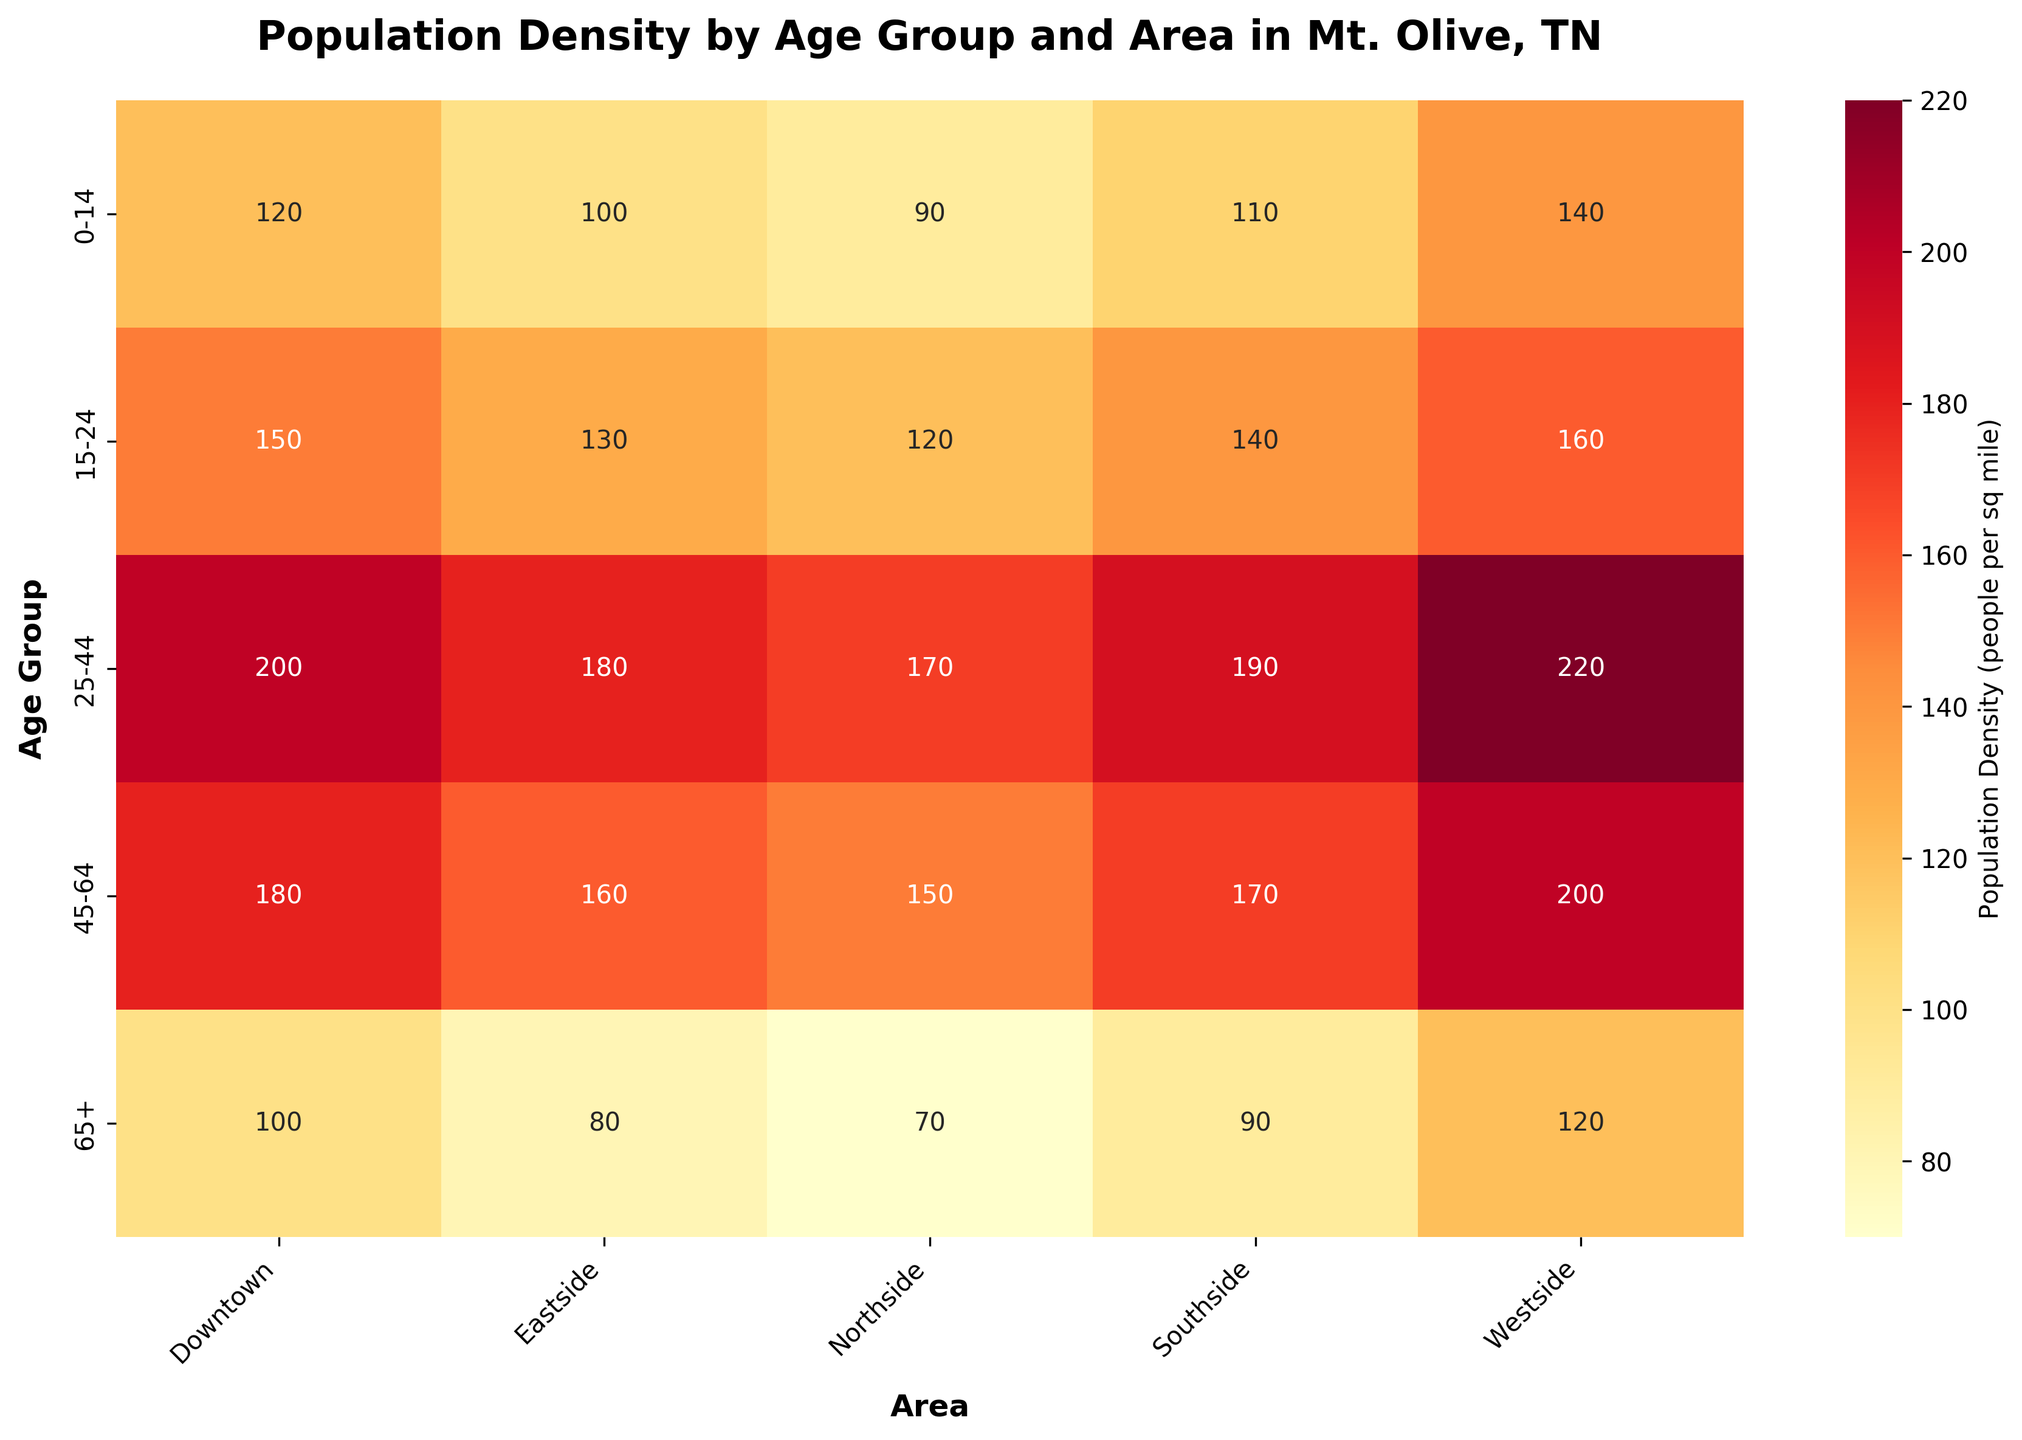How many age groups are represented in the heatmap? The heatmap shows five different age groups vertically along the y-axis. These age groups are 0-14, 15-24, 25-44, 45-64, and 65+.
Answer: 5 What's the total population density for the 'Downtown' area across all age groups? To find the total population density for the 'Downtown' area, sum the values for each age group: 120 (0-14) + 150 (15-24) + 200 (25-44) + 180 (45-64) + 100 (65+). The total is 750.
Answer: 750 Which age group has the highest population density in the 'Westside' area? By looking at the 'Westside' column, you can see that the values for each age group are 140 (0-14), 160 (15-24), 220 (25-44), 200 (45-64), and 120 (65+). The highest density is 220 for the age group 25-44.
Answer: 25-44 How does the population density for the age group 65+ in 'Eastside' compare to 'Southside'? The population density for the age group 65+ in the 'Eastside' is 80 and in the 'Southside' is 90. Comparing these, the 'Southside' has a higher population density.
Answer: Southside has a higher population density What is the average population density for the age group 15-24 across all areas? Calculate the average by summing the densities for the age group 15-24 across all areas and then dividing by the number of areas: (150+130+160+120+140) / 5 = 700 / 5 = 140.
Answer: 140 Which area has the lowest population density for the age group 45-64? By examining the values for the age group 45-64 across all areas: Downtown (180), Eastside (160), Westside (200), Northside (150), Southside (170), the lowest density is in 'Northside' with 150.
Answer: Northside In which area is the population density for the 25-44 age group higher than both the 15-24 and 45-64 age groups? Look at each area where the 25-44 density is higher than both 15-24 and 45-64: 
- Downtown: 200 (25-44) > 150 (15-24) & 200 > 180 (45-64) ✅
- Eastside: 180 (25-44) > 130 (15-24) & 180 > 160 (45-64) ✅
- Westside: 220 (25-44) > 160 (15-24) & 220 > 200 (45-64) ✅
- Northside: 170 (25-44) > 120 (15-24) & 170 > 150 (45-64) ✅
- Southside: 190 (25-44) > 140 (15-24) & 190 > 170 (45-64) ✅
All areas have higher population density in the 25-44 age group compared to both 15-24 and 45-64 age groups.
Answer: All areas Which combination of age group and area has the lowest population density? By scanning the heatmap, the lowest population density value is 70, which corresponds to the 65+ age group in the 'Northside' area.
Answer: 65+ in Northside Is the population density for the 25-44 age group in 'Southside' greater than the population densities for the 0-14 and 65+ age groups in 'Downtown'? Compare the values: 
- 25-44 in 'Southside': 190 
- 0-14 in 'Downtown': 120 
- 65+ in 'Downtown': 100
190 (Southside 25-44) > 120 (Downtown 0-14) & 190 > 100 (Downtown 65+). So, it is greater.
Answer: Yes Considering all areas, which age group shows the highest variation in population density? To determine this, observe the ranges (difference between highest and lowest values) of population density for each age group across all areas:
- 0-14: 140 - 90 = 50
- 15-24: 160 - 120 = 40
- 25-44: 220 - 170 = 50
- 45-64: 200 - 150 = 50
- 65+: 120 - 70 = 50
All age groups except 15-24 have the same highest variation of 50. So, 0-14, 25-44, 45-64, and 65+ have the highest variation in population density.
Answer: 0-14, 25-44, 45-64, and 65+ 